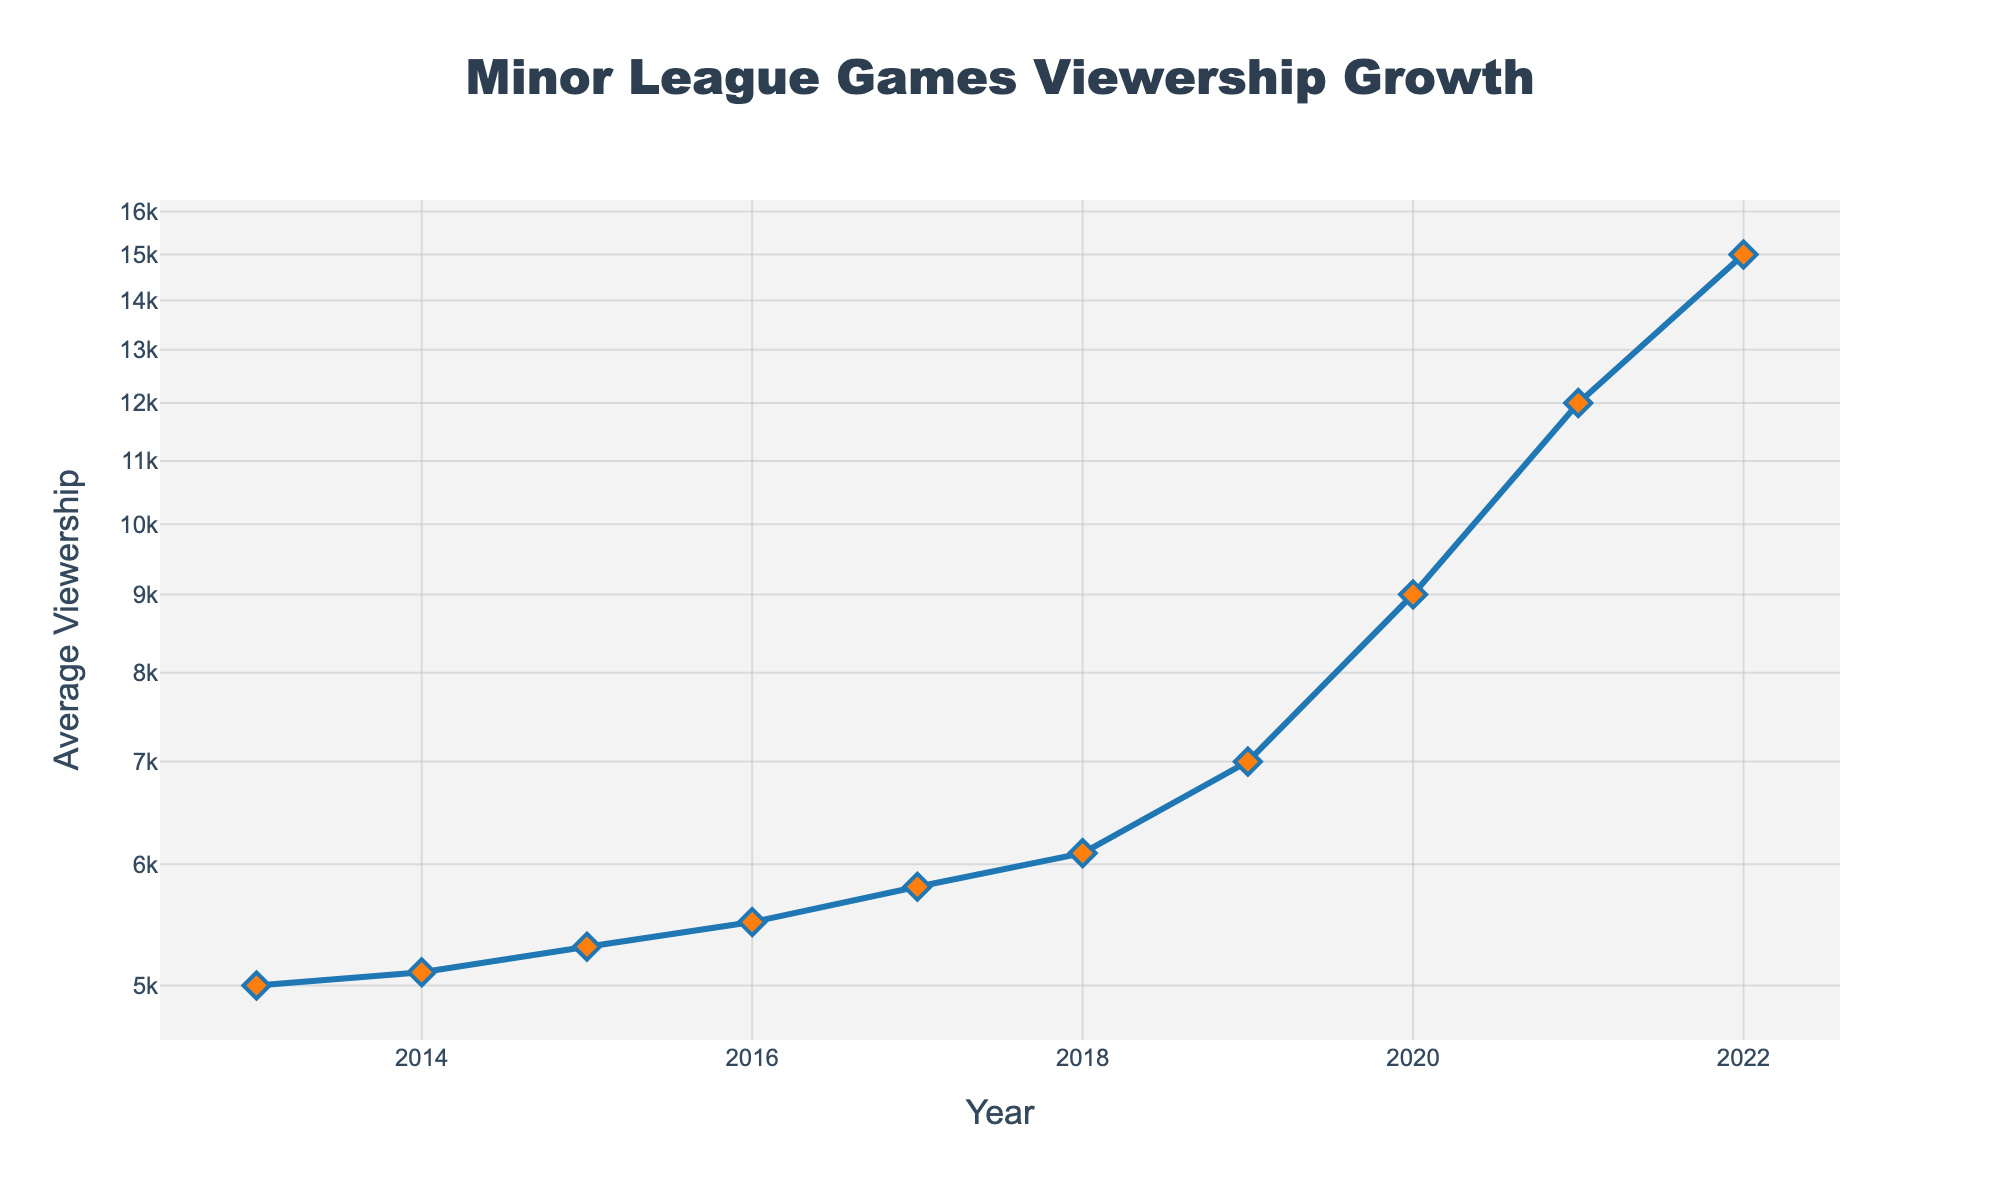What is the title of the figure? The title of the figure is displayed at the top of the chart. It reads "Minor League Games Viewership Growth".
Answer: Minor League Games Viewership Growth How many years of data are displayed in the figure? The x-axis ranges from 2013 to 2022, marking each year. Counting these, there are 10 years of data presented.
Answer: 10 What is the general trend observed in the viewership from 2013 to 2022? The line plot shows an increasing trend in average viewership over time, with a marked acceleration in growth after 2018.
Answer: Increasing What is the average viewership in 2022 according to the plot? By locating the data point for the year 2022 on the plot, we can see that the average viewership is approximately 15,000.
Answer: 15000 In which year did the average viewership first exceed 10,000? By inspecting the y-axis and noting the data points, we see that the average viewership first exceeds 10,000 in 2021.
Answer: 2021 What is the increase in average viewership from 2017 to 2022? The average viewership in 2017 is 5800, and in 2022, it is 15000. The increase is calculated as 15000 - 5800, which equals 9200.
Answer: 9200 How does the viewership in 2020 compare to that in 2013? In 2013, the average viewership is 5000, and in 2020, it is 9000. Therefore, the viewership in 2020 is almost double that of 2013.
Answer: Doubled When did the most significant change in viewership occur, according to the plot annotation? The plot annotation indicates that exponential growth is observed around 2018, suggesting substantial changes around this year.
Answer: 2018 What is the compound annual growth rate (CAGR) of viewership from 2013 to 2022? CAGR is calculated using the formula: [(15000/5000)^(1/9) - 1]. This approximates to [(3)^(1/9) - 1], about 13% per year.
Answer: ~13% As indicated in the annotation, why would one describe the growth pattern from 2018 onward as "exponential"? From 2018 onward, the slope of the viewership line becomes steeper, indicating a rapid increase in viewership over a short period, typical of exponential growth.
Answer: Rapid increase 